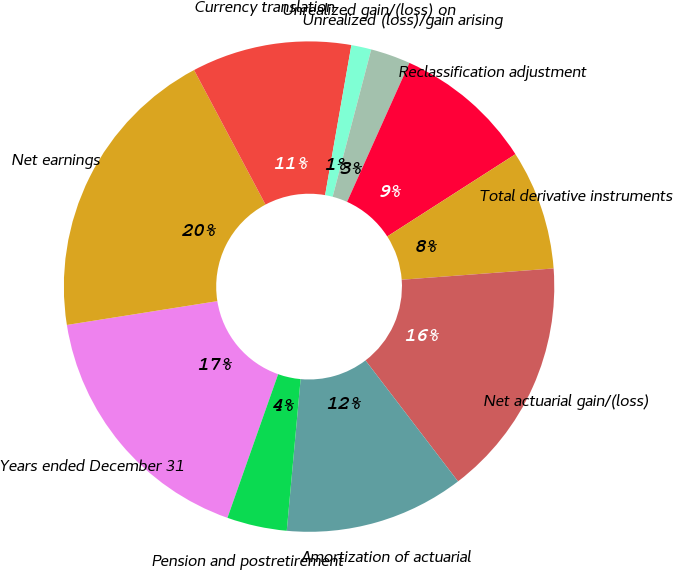<chart> <loc_0><loc_0><loc_500><loc_500><pie_chart><fcel>Years ended December 31<fcel>Net earnings<fcel>Currency translation<fcel>Unrealized gain/(loss) on<fcel>Unrealized (loss)/gain arising<fcel>Reclassification adjustment<fcel>Total derivative instruments<fcel>Net actuarial gain/(loss)<fcel>Amortization of actuarial<fcel>Pension and postretirement<nl><fcel>17.1%<fcel>19.73%<fcel>10.53%<fcel>1.32%<fcel>2.63%<fcel>9.21%<fcel>7.9%<fcel>15.79%<fcel>11.84%<fcel>3.95%<nl></chart> 